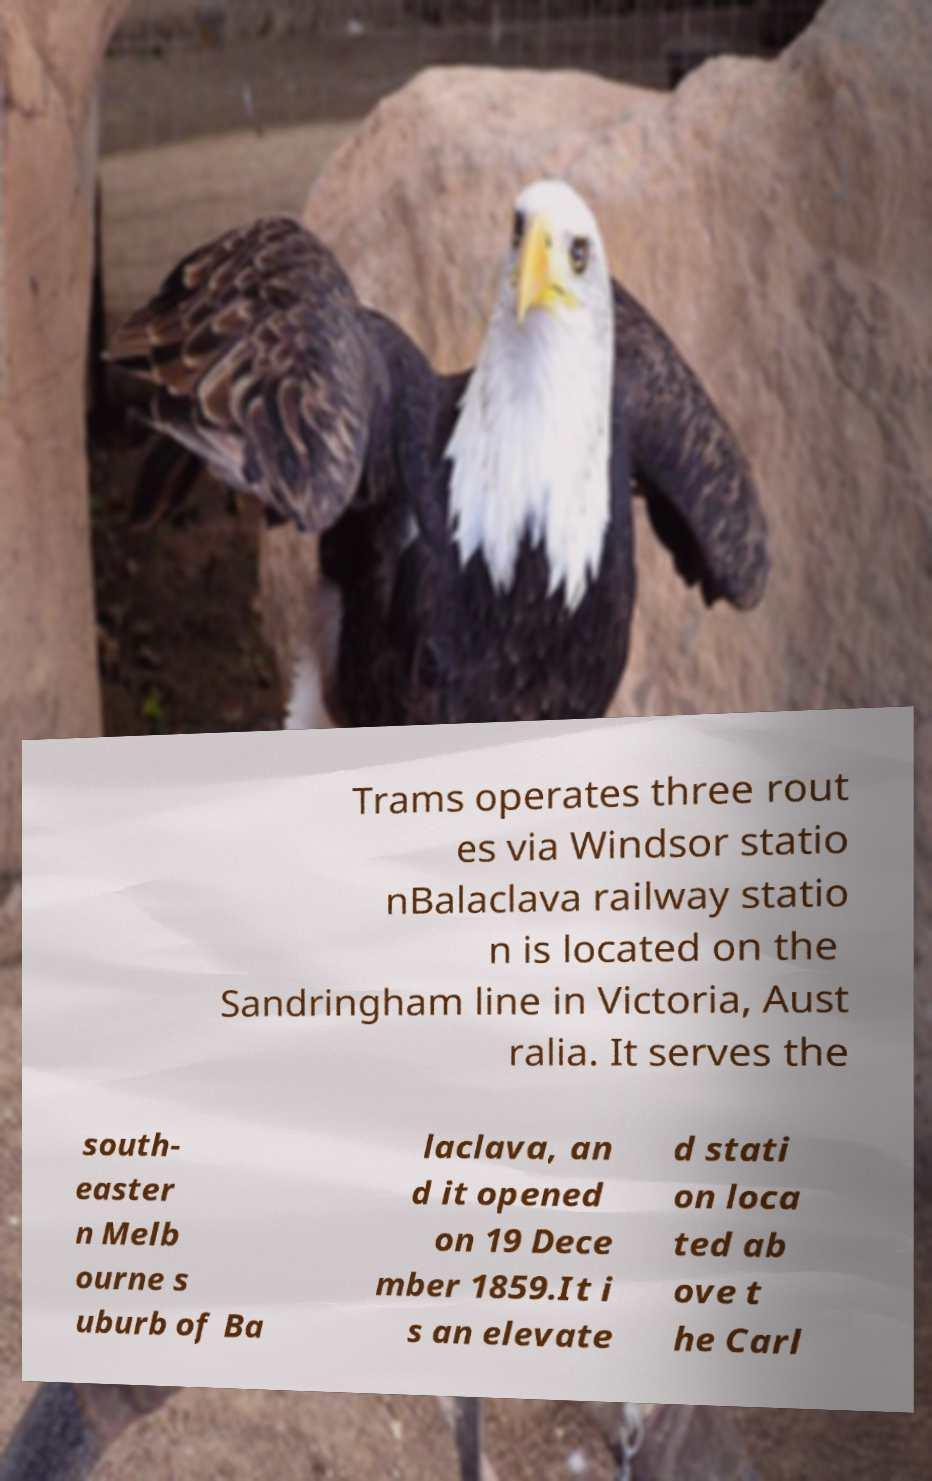Can you accurately transcribe the text from the provided image for me? Trams operates three rout es via Windsor statio nBalaclava railway statio n is located on the Sandringham line in Victoria, Aust ralia. It serves the south- easter n Melb ourne s uburb of Ba laclava, an d it opened on 19 Dece mber 1859.It i s an elevate d stati on loca ted ab ove t he Carl 